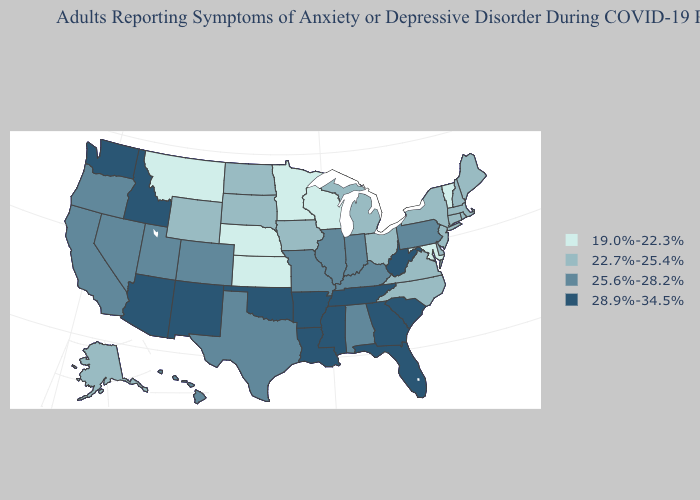Does Washington have the highest value in the West?
Be succinct. Yes. Does Alaska have the same value as Illinois?
Short answer required. No. Does Montana have the lowest value in the West?
Quick response, please. Yes. Among the states that border Louisiana , which have the highest value?
Keep it brief. Arkansas, Mississippi. What is the lowest value in the USA?
Quick response, please. 19.0%-22.3%. Does the map have missing data?
Concise answer only. No. Name the states that have a value in the range 22.7%-25.4%?
Short answer required. Alaska, Connecticut, Delaware, Iowa, Maine, Massachusetts, Michigan, New Hampshire, New Jersey, New York, North Carolina, North Dakota, Ohio, Rhode Island, South Dakota, Virginia, Wyoming. Which states hav the highest value in the Northeast?
Write a very short answer. Pennsylvania. Does the map have missing data?
Short answer required. No. What is the value of New Hampshire?
Keep it brief. 22.7%-25.4%. Does Ohio have the same value as New Jersey?
Give a very brief answer. Yes. Among the states that border Ohio , does Kentucky have the highest value?
Short answer required. No. Is the legend a continuous bar?
Keep it brief. No. Does Oklahoma have the highest value in the South?
Quick response, please. Yes. What is the value of Oregon?
Write a very short answer. 25.6%-28.2%. 